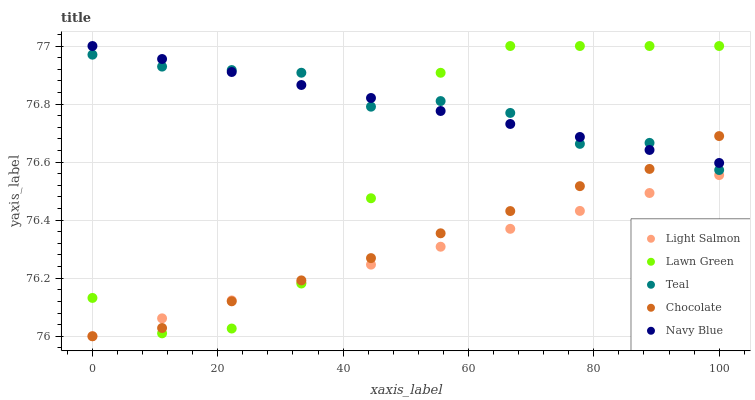Does Light Salmon have the minimum area under the curve?
Answer yes or no. Yes. Does Teal have the maximum area under the curve?
Answer yes or no. Yes. Does Navy Blue have the minimum area under the curve?
Answer yes or no. No. Does Navy Blue have the maximum area under the curve?
Answer yes or no. No. Is Navy Blue the smoothest?
Answer yes or no. Yes. Is Lawn Green the roughest?
Answer yes or no. Yes. Is Light Salmon the smoothest?
Answer yes or no. No. Is Light Salmon the roughest?
Answer yes or no. No. Does Light Salmon have the lowest value?
Answer yes or no. Yes. Does Navy Blue have the lowest value?
Answer yes or no. No. Does Navy Blue have the highest value?
Answer yes or no. Yes. Does Light Salmon have the highest value?
Answer yes or no. No. Is Light Salmon less than Navy Blue?
Answer yes or no. Yes. Is Navy Blue greater than Light Salmon?
Answer yes or no. Yes. Does Teal intersect Chocolate?
Answer yes or no. Yes. Is Teal less than Chocolate?
Answer yes or no. No. Is Teal greater than Chocolate?
Answer yes or no. No. Does Light Salmon intersect Navy Blue?
Answer yes or no. No. 